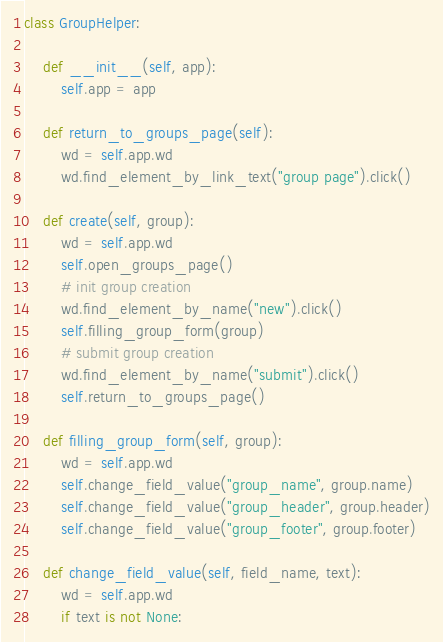<code> <loc_0><loc_0><loc_500><loc_500><_Python_>

class GroupHelper:

    def __init__(self, app):
        self.app = app

    def return_to_groups_page(self):
        wd = self.app.wd
        wd.find_element_by_link_text("group page").click()

    def create(self, group):
        wd = self.app.wd
        self.open_groups_page()
        # init group creation
        wd.find_element_by_name("new").click()
        self.filling_group_form(group)
        # submit group creation
        wd.find_element_by_name("submit").click()
        self.return_to_groups_page()

    def filling_group_form(self, group):
        wd = self.app.wd
        self.change_field_value("group_name", group.name)
        self.change_field_value("group_header", group.header)
        self.change_field_value("group_footer", group.footer)

    def change_field_value(self, field_name, text):
        wd = self.app.wd
        if text is not None:</code> 